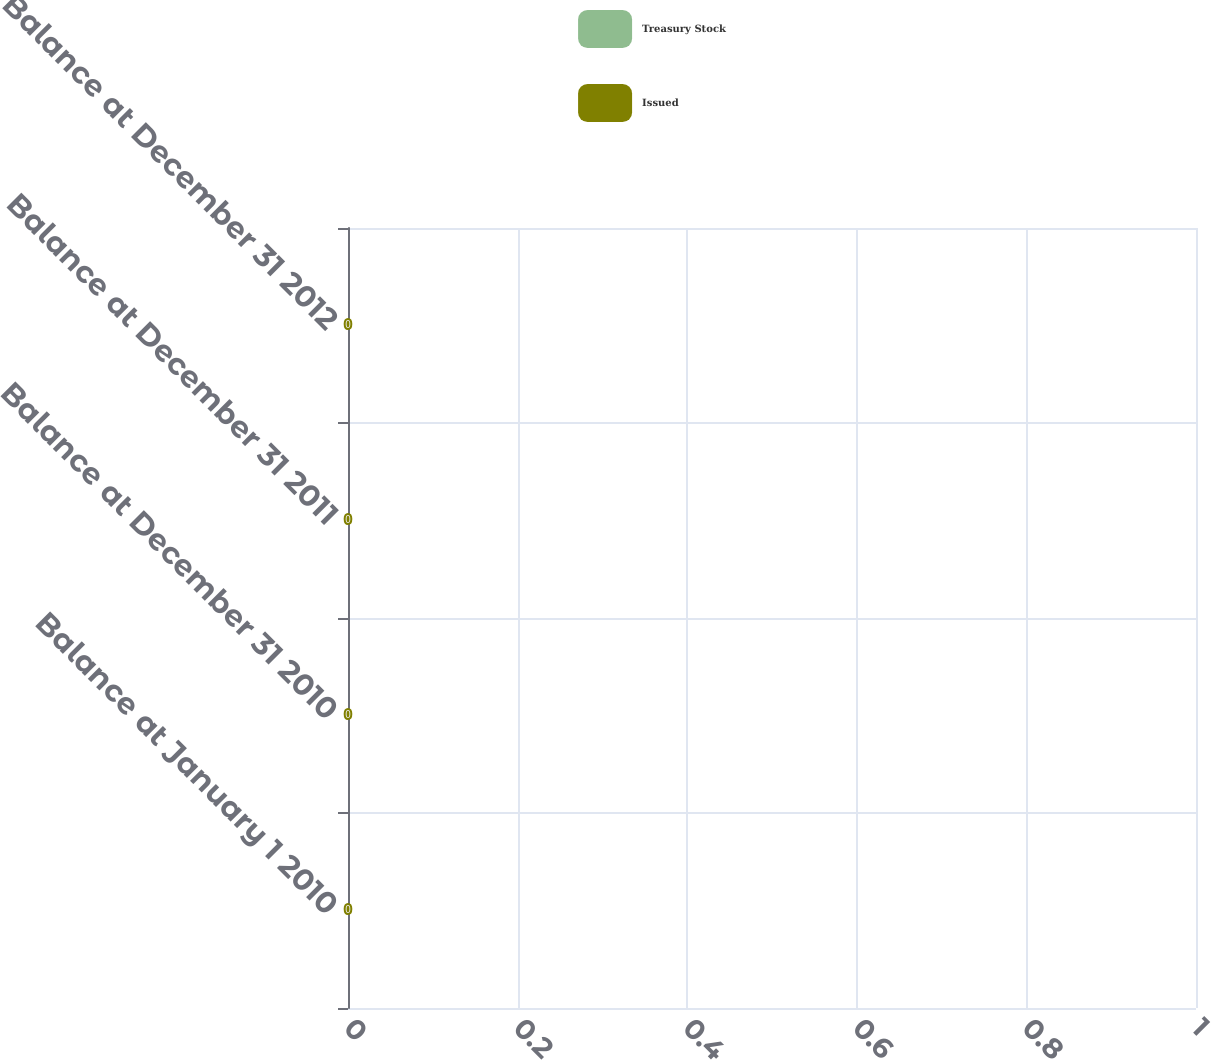<chart> <loc_0><loc_0><loc_500><loc_500><stacked_bar_chart><ecel><fcel>Balance at January 1 2010<fcel>Balance at December 31 2010<fcel>Balance at December 31 2011<fcel>Balance at December 31 2012<nl><fcel>Treasury Stock<fcel>0<fcel>0<fcel>0<fcel>0<nl><fcel>Issued<fcel>0<fcel>0<fcel>0<fcel>0<nl></chart> 